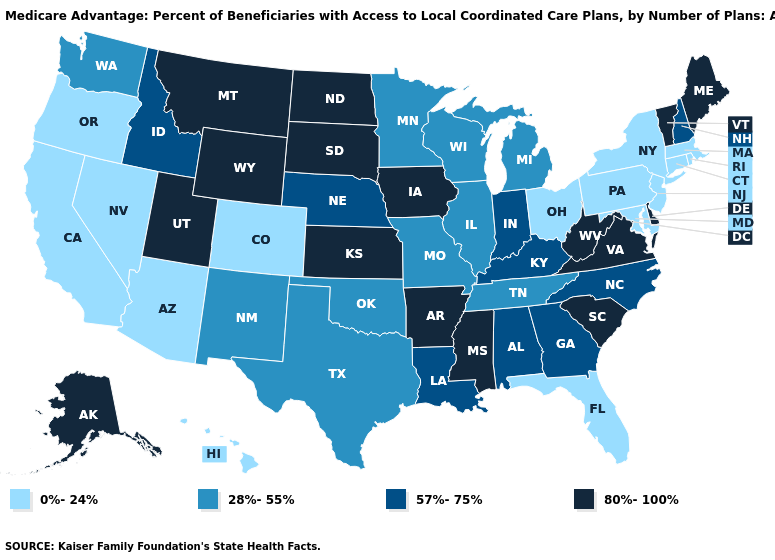What is the value of Missouri?
Keep it brief. 28%-55%. Name the states that have a value in the range 0%-24%?
Quick response, please. Arizona, California, Colorado, Connecticut, Florida, Hawaii, Massachusetts, Maryland, New Jersey, Nevada, New York, Ohio, Oregon, Pennsylvania, Rhode Island. Name the states that have a value in the range 0%-24%?
Concise answer only. Arizona, California, Colorado, Connecticut, Florida, Hawaii, Massachusetts, Maryland, New Jersey, Nevada, New York, Ohio, Oregon, Pennsylvania, Rhode Island. Does the map have missing data?
Give a very brief answer. No. Name the states that have a value in the range 28%-55%?
Give a very brief answer. Illinois, Michigan, Minnesota, Missouri, New Mexico, Oklahoma, Tennessee, Texas, Washington, Wisconsin. Name the states that have a value in the range 0%-24%?
Quick response, please. Arizona, California, Colorado, Connecticut, Florida, Hawaii, Massachusetts, Maryland, New Jersey, Nevada, New York, Ohio, Oregon, Pennsylvania, Rhode Island. Name the states that have a value in the range 28%-55%?
Concise answer only. Illinois, Michigan, Minnesota, Missouri, New Mexico, Oklahoma, Tennessee, Texas, Washington, Wisconsin. Name the states that have a value in the range 80%-100%?
Quick response, please. Alaska, Arkansas, Delaware, Iowa, Kansas, Maine, Mississippi, Montana, North Dakota, South Carolina, South Dakota, Utah, Virginia, Vermont, West Virginia, Wyoming. Which states have the highest value in the USA?
Quick response, please. Alaska, Arkansas, Delaware, Iowa, Kansas, Maine, Mississippi, Montana, North Dakota, South Carolina, South Dakota, Utah, Virginia, Vermont, West Virginia, Wyoming. Which states have the highest value in the USA?
Write a very short answer. Alaska, Arkansas, Delaware, Iowa, Kansas, Maine, Mississippi, Montana, North Dakota, South Carolina, South Dakota, Utah, Virginia, Vermont, West Virginia, Wyoming. How many symbols are there in the legend?
Keep it brief. 4. Name the states that have a value in the range 28%-55%?
Be succinct. Illinois, Michigan, Minnesota, Missouri, New Mexico, Oklahoma, Tennessee, Texas, Washington, Wisconsin. Which states have the lowest value in the USA?
Be succinct. Arizona, California, Colorado, Connecticut, Florida, Hawaii, Massachusetts, Maryland, New Jersey, Nevada, New York, Ohio, Oregon, Pennsylvania, Rhode Island. Does Vermont have the highest value in the Northeast?
Give a very brief answer. Yes. What is the value of California?
Be succinct. 0%-24%. 